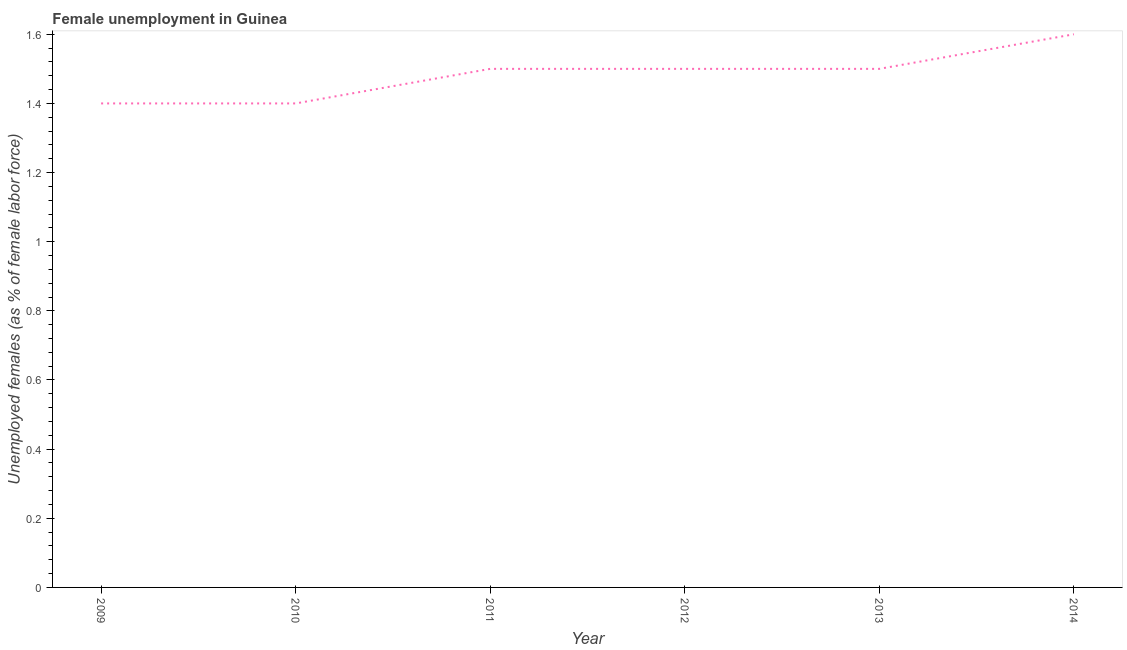Across all years, what is the maximum unemployed females population?
Give a very brief answer. 1.6. Across all years, what is the minimum unemployed females population?
Keep it short and to the point. 1.4. In which year was the unemployed females population maximum?
Ensure brevity in your answer.  2014. In which year was the unemployed females population minimum?
Make the answer very short. 2009. What is the sum of the unemployed females population?
Ensure brevity in your answer.  8.9. What is the difference between the unemployed females population in 2013 and 2014?
Ensure brevity in your answer.  -0.1. What is the average unemployed females population per year?
Your response must be concise. 1.48. What is the median unemployed females population?
Keep it short and to the point. 1.5. Do a majority of the years between 2009 and 2014 (inclusive) have unemployed females population greater than 1 %?
Provide a succinct answer. Yes. What is the ratio of the unemployed females population in 2012 to that in 2013?
Ensure brevity in your answer.  1. What is the difference between the highest and the second highest unemployed females population?
Make the answer very short. 0.1. What is the difference between the highest and the lowest unemployed females population?
Keep it short and to the point. 0.2. In how many years, is the unemployed females population greater than the average unemployed females population taken over all years?
Give a very brief answer. 4. How many lines are there?
Your response must be concise. 1. How many years are there in the graph?
Your response must be concise. 6. Does the graph contain any zero values?
Your answer should be very brief. No. Does the graph contain grids?
Your answer should be compact. No. What is the title of the graph?
Your response must be concise. Female unemployment in Guinea. What is the label or title of the X-axis?
Provide a short and direct response. Year. What is the label or title of the Y-axis?
Ensure brevity in your answer.  Unemployed females (as % of female labor force). What is the Unemployed females (as % of female labor force) in 2009?
Ensure brevity in your answer.  1.4. What is the Unemployed females (as % of female labor force) of 2010?
Give a very brief answer. 1.4. What is the Unemployed females (as % of female labor force) in 2012?
Provide a short and direct response. 1.5. What is the Unemployed females (as % of female labor force) of 2013?
Keep it short and to the point. 1.5. What is the Unemployed females (as % of female labor force) of 2014?
Provide a succinct answer. 1.6. What is the difference between the Unemployed females (as % of female labor force) in 2009 and 2011?
Give a very brief answer. -0.1. What is the difference between the Unemployed females (as % of female labor force) in 2009 and 2013?
Give a very brief answer. -0.1. What is the difference between the Unemployed females (as % of female labor force) in 2010 and 2012?
Provide a short and direct response. -0.1. What is the difference between the Unemployed females (as % of female labor force) in 2010 and 2013?
Give a very brief answer. -0.1. What is the difference between the Unemployed females (as % of female labor force) in 2011 and 2012?
Ensure brevity in your answer.  0. What is the difference between the Unemployed females (as % of female labor force) in 2011 and 2014?
Give a very brief answer. -0.1. What is the ratio of the Unemployed females (as % of female labor force) in 2009 to that in 2011?
Offer a very short reply. 0.93. What is the ratio of the Unemployed females (as % of female labor force) in 2009 to that in 2012?
Your answer should be compact. 0.93. What is the ratio of the Unemployed females (as % of female labor force) in 2009 to that in 2013?
Offer a very short reply. 0.93. What is the ratio of the Unemployed females (as % of female labor force) in 2009 to that in 2014?
Ensure brevity in your answer.  0.88. What is the ratio of the Unemployed females (as % of female labor force) in 2010 to that in 2011?
Make the answer very short. 0.93. What is the ratio of the Unemployed females (as % of female labor force) in 2010 to that in 2012?
Provide a short and direct response. 0.93. What is the ratio of the Unemployed females (as % of female labor force) in 2010 to that in 2013?
Offer a very short reply. 0.93. What is the ratio of the Unemployed females (as % of female labor force) in 2011 to that in 2012?
Keep it short and to the point. 1. What is the ratio of the Unemployed females (as % of female labor force) in 2011 to that in 2014?
Make the answer very short. 0.94. What is the ratio of the Unemployed females (as % of female labor force) in 2012 to that in 2014?
Your answer should be very brief. 0.94. What is the ratio of the Unemployed females (as % of female labor force) in 2013 to that in 2014?
Provide a short and direct response. 0.94. 